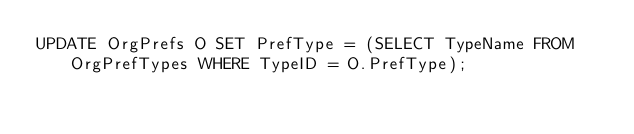Convert code to text. <code><loc_0><loc_0><loc_500><loc_500><_SQL_>UPDATE OrgPrefs O SET PrefType = (SELECT TypeName FROM OrgPrefTypes WHERE TypeID = O.PrefType);

</code> 